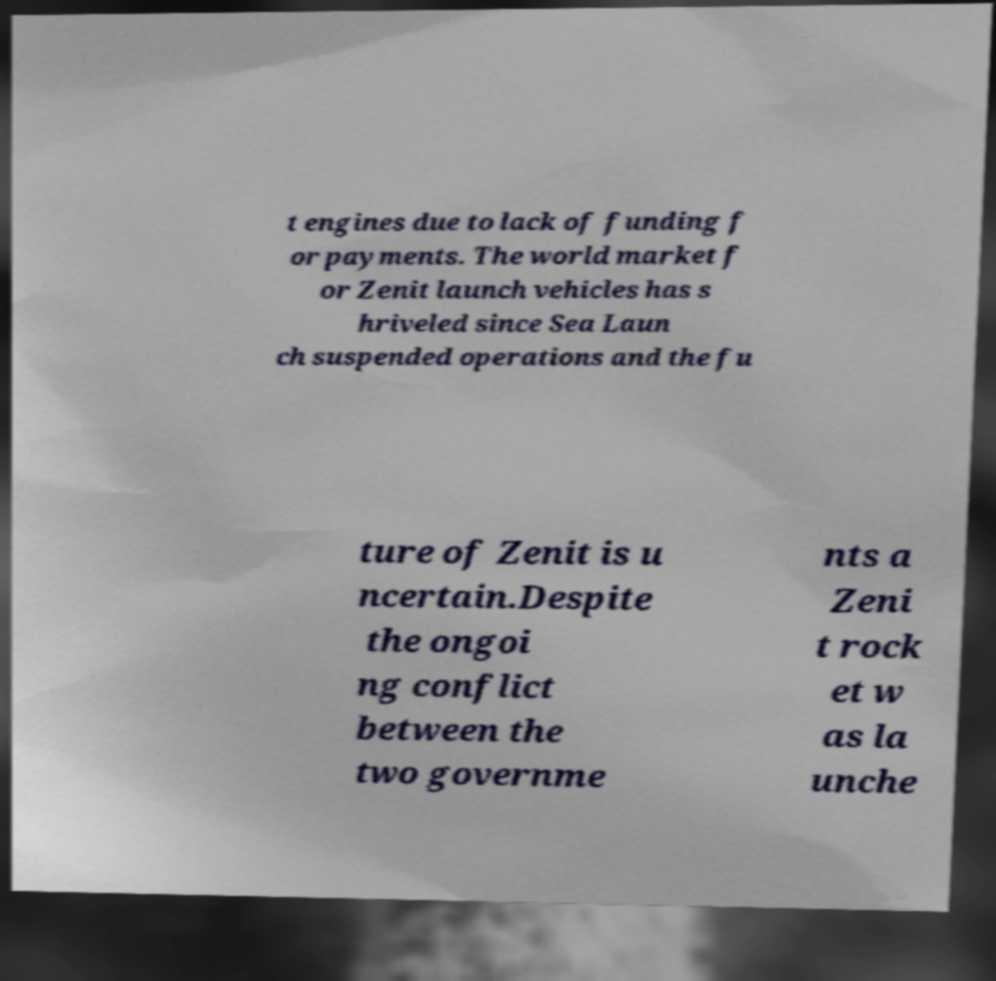Please read and relay the text visible in this image. What does it say? t engines due to lack of funding f or payments. The world market f or Zenit launch vehicles has s hriveled since Sea Laun ch suspended operations and the fu ture of Zenit is u ncertain.Despite the ongoi ng conflict between the two governme nts a Zeni t rock et w as la unche 